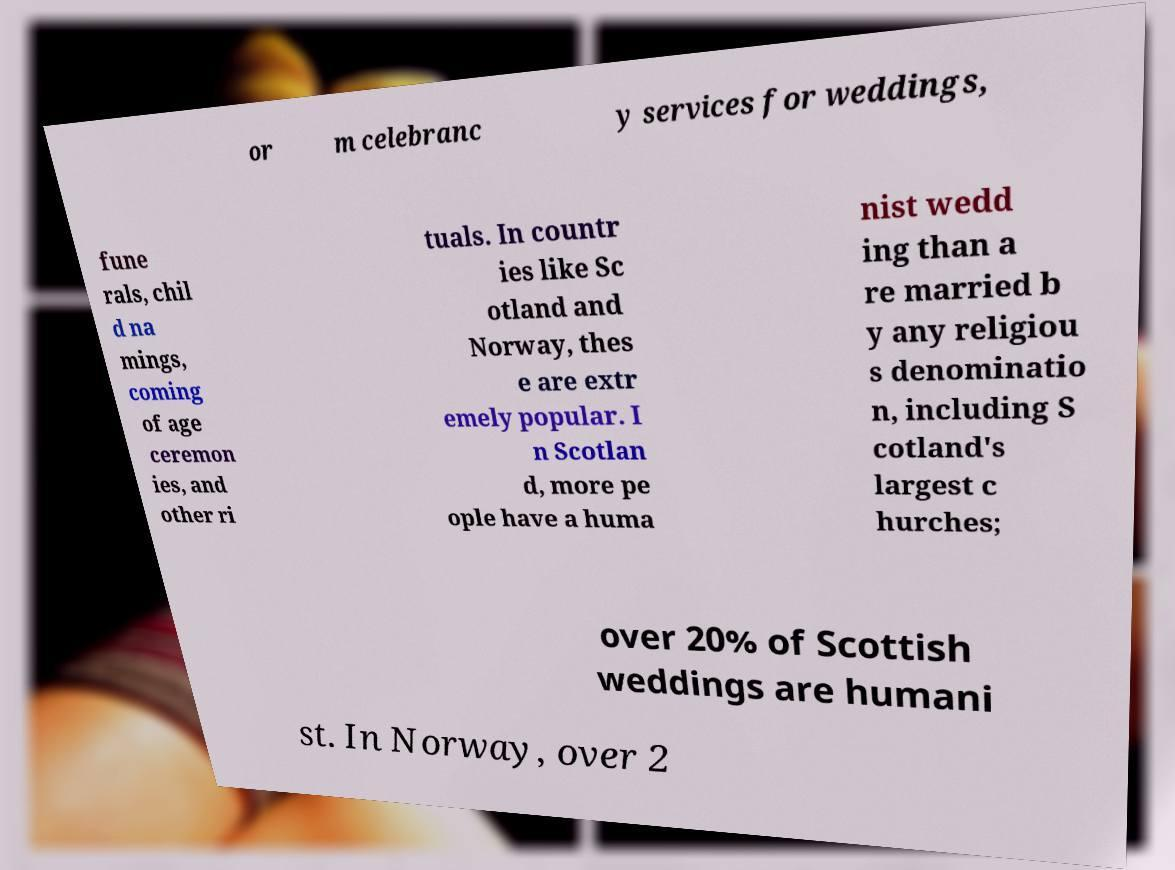Could you extract and type out the text from this image? or m celebranc y services for weddings, fune rals, chil d na mings, coming of age ceremon ies, and other ri tuals. In countr ies like Sc otland and Norway, thes e are extr emely popular. I n Scotlan d, more pe ople have a huma nist wedd ing than a re married b y any religiou s denominatio n, including S cotland's largest c hurches; over 20% of Scottish weddings are humani st. In Norway, over 2 